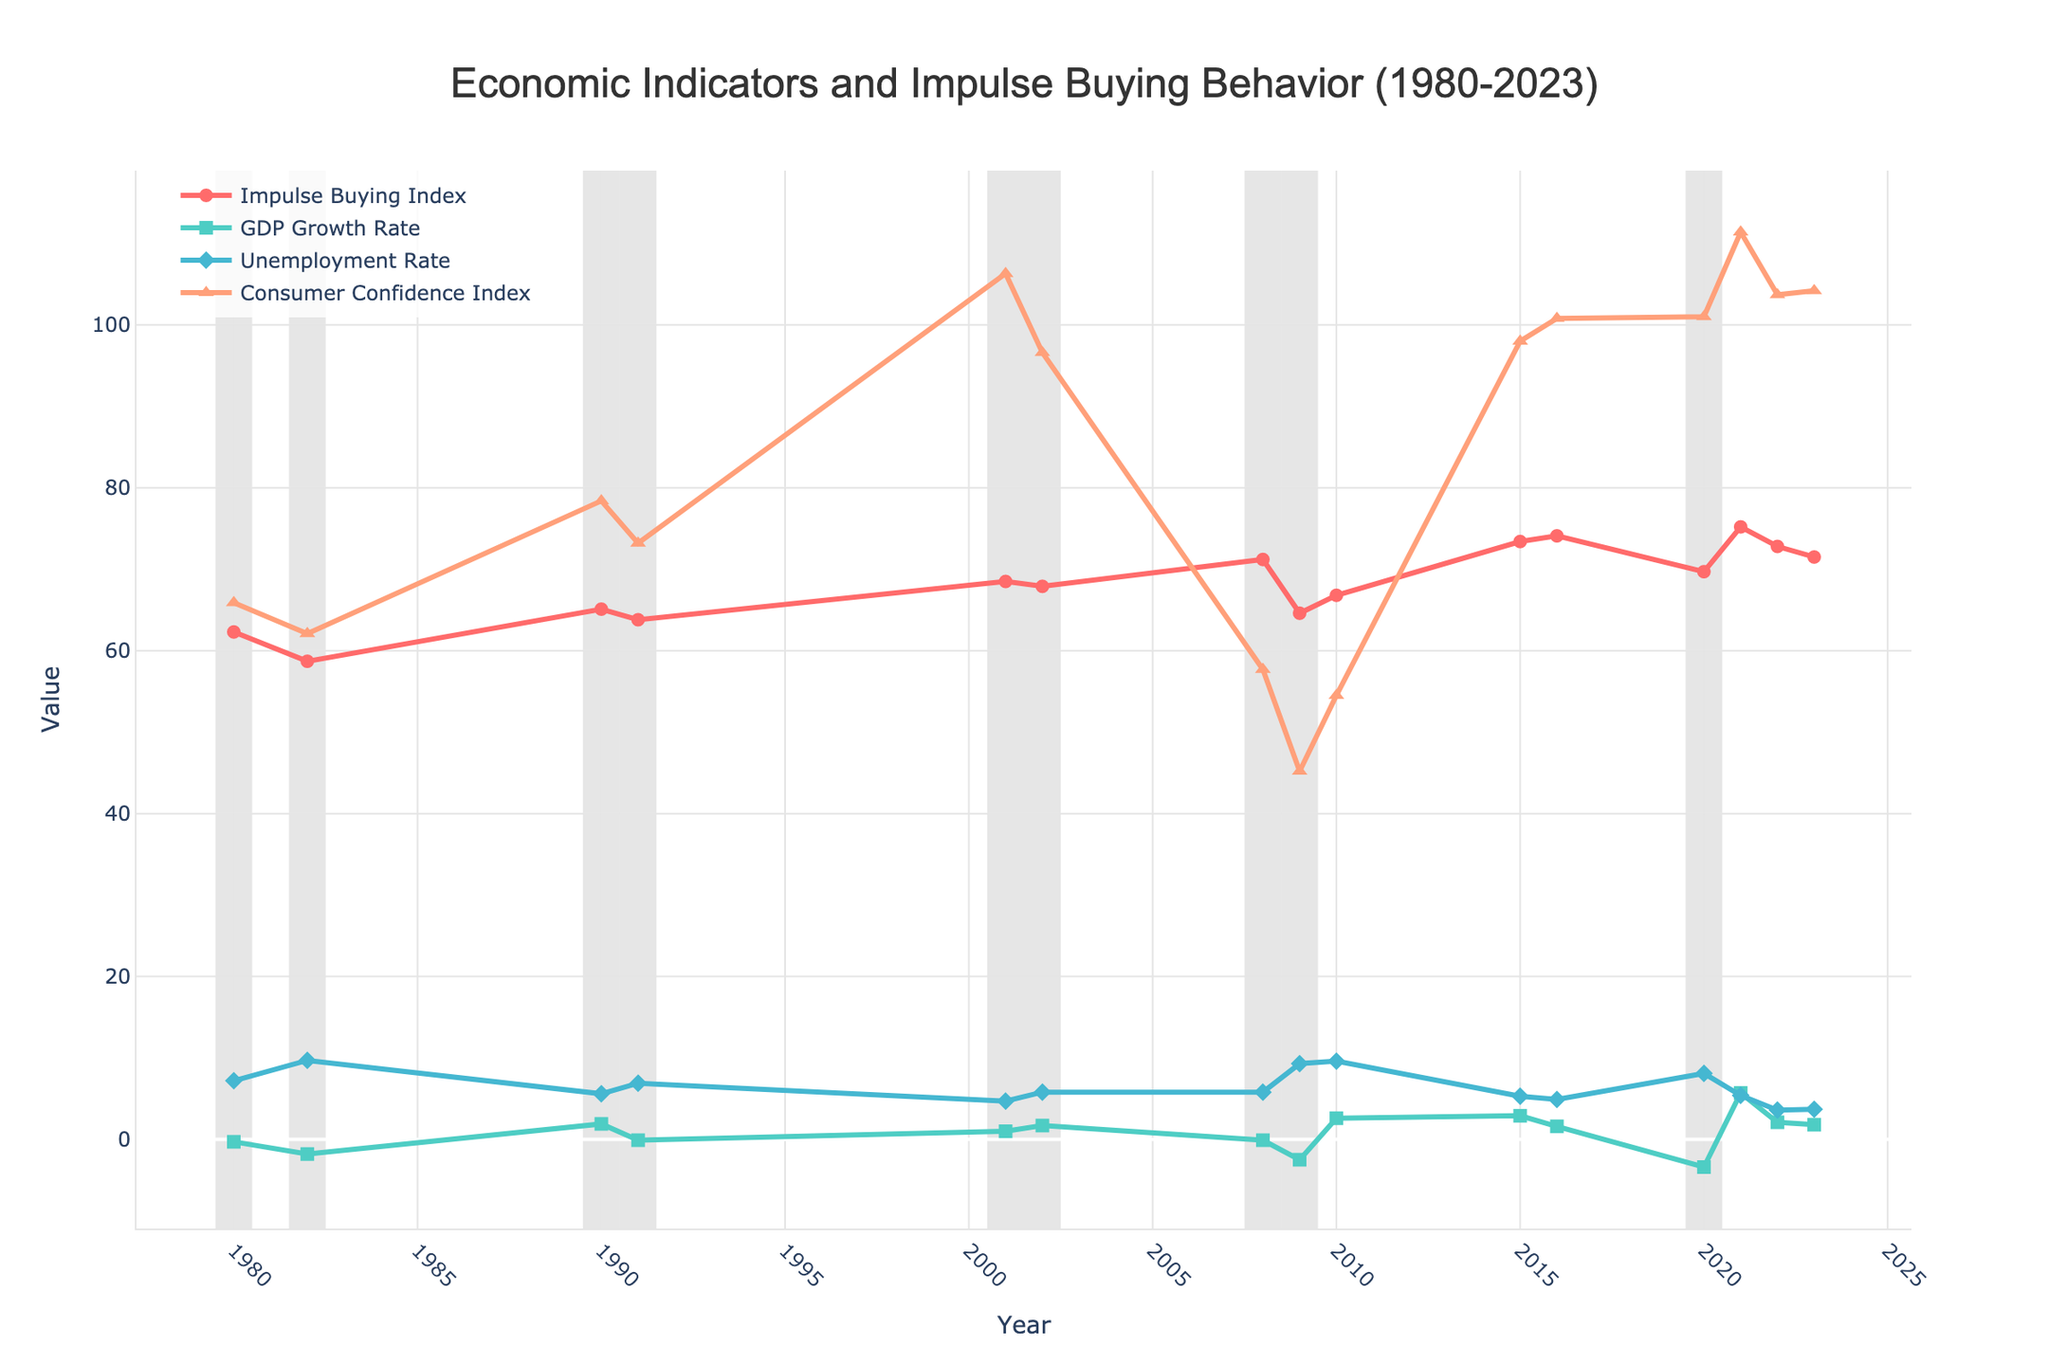What is the trend in the Impulse Buying Index during the recession years? The recession years of 1980, 1982, 1990, 1991, 2001, 2002, 2008, 2009, and 2020 show varying patterns in the Impulse Buying Index. Generally, the trend fluctuates, with decreases in 1982, 2009, and 2020, while some years like 2008 and 2001 show higher values compared to other recession periods. This complexity indicates multiple influencing factors during recessions.
Answer: Fluctuating Between 1980 and 2023, which year had the highest Impulse Buying Index and what was its value? By observing the line for the Impulse Buying Index, the highest point appears in the year 2021, marked by the red line and circular markers. Its value is 75.2.
Answer: 2021, 75.2 How does the Impulse Buying Index in 2009 compare to that in 2008? The Impulse Buying Index in 2008 is greater than that in 2009. In 2008, the value is 71.2, and in 2009, it drops to 64.6, as seen by the red line and markers.
Answer: 2009 < 2008 What is the combined value of the Impulse Buying Index and Consumer Confidence Index in 2008? The Impulse Buying Index in 2008 is 71.2, and the Consumer Confidence Index is 57.7. Adding these values together: 71.2 + 57.7 = 128.9.
Answer: 128.9 During which year did the GDP Growth Rate have the sharpest decline, and what was the corresponding Impulse Buying Index in that year? The sharpest decline in GDP Growth Rate is observed from 2020 to 2021, where it drops significantly to -3.4 in 2020. The corresponding Impulse Buying Index during that year (2020) is 69.7, shown in the green and red lines.
Answer: 2020, 69.7 Which year had the highest Unemployment Rate, and what impact did it have on the Impulse Buying Index for that year? The highest Unemployment Rate is in 1982 at 9.7. During this year, the Impulse Buying Index was at a low of 58.7, suggesting a potential negative relationship between high unemployment and impulse buying behavior.
Answer: 1982, Negative Impact In 2010, what are the values of the Impulse Buying Index, GDP Growth Rate, and the difference between the Unemployment Rate and Consumer Confidence Index? In 2010, Impulse Buying Index is 66.8, GDP Growth Rate is 2.6, Unemployment Rate is 9.6, and Consumer Confidence Index is 54.5. The difference between the Unemployment Rate and Consumer Confidence Index is 9.6 - 54.5 = -44.9.
Answer: 66.8, 2.6, -44.9 How does the Impulse Buying Index in 2023 compare to that in 2021, and what does this indicate about the consumer behavior over these years? The Impulse Buying Index in 2023 is 71.5, which is lower than the peak of 75.2 recorded in 2021. This indicates a slight decrease in impulse buying behavior from 2021 to 2023.
Answer: 2023 < 2021, Decrease What was the trend of the Consumer Confidence Index from 2008 to 2023, and how did it correlate with the Impulse Buying Index? The Consumer Confidence Index shows an upward trend from 2008 (57.7) to 2023 (104.2). The Impulse Buying Index also generally increases over this period, albeit with fluctuations. This suggests a positive correlation between consumer confidence and impulse buying behavior.
Answer: Upward, Positive Correlation 